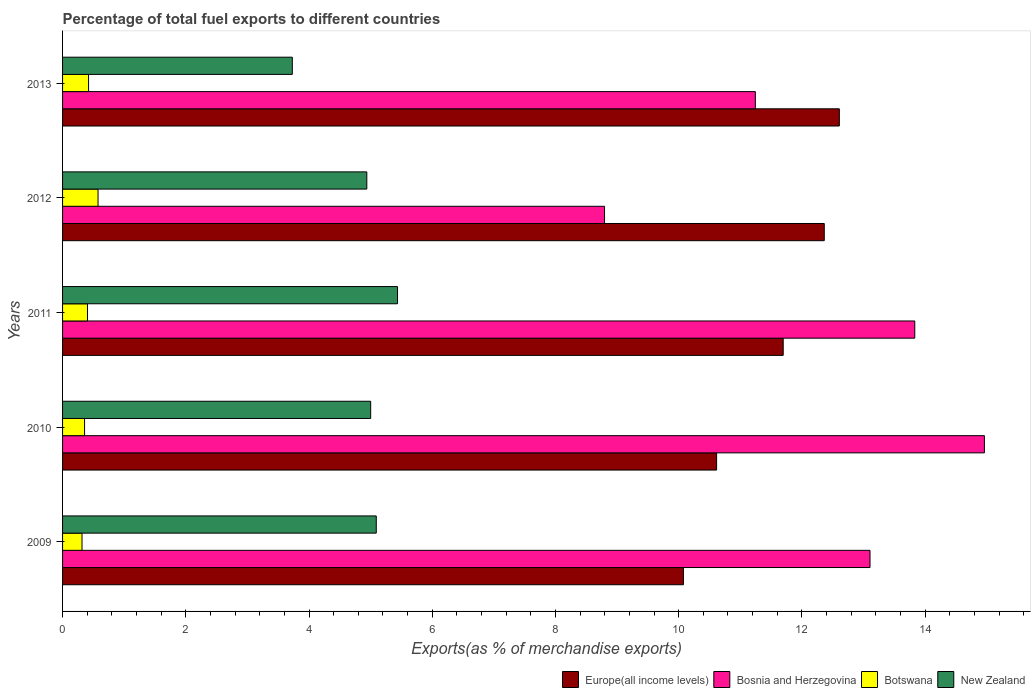How many groups of bars are there?
Your answer should be very brief. 5. Are the number of bars on each tick of the Y-axis equal?
Provide a short and direct response. Yes. How many bars are there on the 4th tick from the top?
Your response must be concise. 4. How many bars are there on the 3rd tick from the bottom?
Your answer should be compact. 4. What is the label of the 2nd group of bars from the top?
Provide a short and direct response. 2012. What is the percentage of exports to different countries in Botswana in 2010?
Your response must be concise. 0.36. Across all years, what is the maximum percentage of exports to different countries in New Zealand?
Your answer should be compact. 5.44. Across all years, what is the minimum percentage of exports to different countries in Botswana?
Keep it short and to the point. 0.32. In which year was the percentage of exports to different countries in Europe(all income levels) minimum?
Your answer should be compact. 2009. What is the total percentage of exports to different countries in Bosnia and Herzegovina in the graph?
Provide a short and direct response. 61.94. What is the difference between the percentage of exports to different countries in Europe(all income levels) in 2010 and that in 2011?
Keep it short and to the point. -1.08. What is the difference between the percentage of exports to different countries in Bosnia and Herzegovina in 2010 and the percentage of exports to different countries in Europe(all income levels) in 2011?
Keep it short and to the point. 3.27. What is the average percentage of exports to different countries in Botswana per year?
Ensure brevity in your answer.  0.42. In the year 2011, what is the difference between the percentage of exports to different countries in New Zealand and percentage of exports to different countries in Bosnia and Herzegovina?
Provide a short and direct response. -8.4. What is the ratio of the percentage of exports to different countries in New Zealand in 2009 to that in 2013?
Provide a short and direct response. 1.37. Is the difference between the percentage of exports to different countries in New Zealand in 2009 and 2013 greater than the difference between the percentage of exports to different countries in Bosnia and Herzegovina in 2009 and 2013?
Provide a succinct answer. No. What is the difference between the highest and the second highest percentage of exports to different countries in Botswana?
Your answer should be compact. 0.15. What is the difference between the highest and the lowest percentage of exports to different countries in Botswana?
Your answer should be compact. 0.26. Is it the case that in every year, the sum of the percentage of exports to different countries in Botswana and percentage of exports to different countries in New Zealand is greater than the sum of percentage of exports to different countries in Bosnia and Herzegovina and percentage of exports to different countries in Europe(all income levels)?
Your answer should be compact. No. What does the 2nd bar from the top in 2009 represents?
Provide a succinct answer. Botswana. What does the 2nd bar from the bottom in 2012 represents?
Offer a very short reply. Bosnia and Herzegovina. Is it the case that in every year, the sum of the percentage of exports to different countries in Europe(all income levels) and percentage of exports to different countries in Bosnia and Herzegovina is greater than the percentage of exports to different countries in Botswana?
Make the answer very short. Yes. Does the graph contain any zero values?
Offer a very short reply. No. Where does the legend appear in the graph?
Provide a short and direct response. Bottom right. How many legend labels are there?
Give a very brief answer. 4. What is the title of the graph?
Your response must be concise. Percentage of total fuel exports to different countries. What is the label or title of the X-axis?
Ensure brevity in your answer.  Exports(as % of merchandise exports). What is the Exports(as % of merchandise exports) in Europe(all income levels) in 2009?
Ensure brevity in your answer.  10.08. What is the Exports(as % of merchandise exports) of Bosnia and Herzegovina in 2009?
Ensure brevity in your answer.  13.11. What is the Exports(as % of merchandise exports) in Botswana in 2009?
Your answer should be very brief. 0.32. What is the Exports(as % of merchandise exports) in New Zealand in 2009?
Offer a very short reply. 5.09. What is the Exports(as % of merchandise exports) of Europe(all income levels) in 2010?
Provide a succinct answer. 10.62. What is the Exports(as % of merchandise exports) of Bosnia and Herzegovina in 2010?
Make the answer very short. 14.96. What is the Exports(as % of merchandise exports) of Botswana in 2010?
Your answer should be compact. 0.36. What is the Exports(as % of merchandise exports) in New Zealand in 2010?
Your answer should be compact. 5. What is the Exports(as % of merchandise exports) in Europe(all income levels) in 2011?
Ensure brevity in your answer.  11.7. What is the Exports(as % of merchandise exports) of Bosnia and Herzegovina in 2011?
Keep it short and to the point. 13.83. What is the Exports(as % of merchandise exports) of Botswana in 2011?
Keep it short and to the point. 0.4. What is the Exports(as % of merchandise exports) in New Zealand in 2011?
Your response must be concise. 5.44. What is the Exports(as % of merchandise exports) in Europe(all income levels) in 2012?
Provide a short and direct response. 12.36. What is the Exports(as % of merchandise exports) in Bosnia and Herzegovina in 2012?
Your answer should be compact. 8.8. What is the Exports(as % of merchandise exports) of Botswana in 2012?
Your response must be concise. 0.58. What is the Exports(as % of merchandise exports) in New Zealand in 2012?
Offer a very short reply. 4.94. What is the Exports(as % of merchandise exports) in Europe(all income levels) in 2013?
Give a very brief answer. 12.61. What is the Exports(as % of merchandise exports) of Bosnia and Herzegovina in 2013?
Give a very brief answer. 11.24. What is the Exports(as % of merchandise exports) in Botswana in 2013?
Your response must be concise. 0.42. What is the Exports(as % of merchandise exports) in New Zealand in 2013?
Give a very brief answer. 3.73. Across all years, what is the maximum Exports(as % of merchandise exports) in Europe(all income levels)?
Your response must be concise. 12.61. Across all years, what is the maximum Exports(as % of merchandise exports) in Bosnia and Herzegovina?
Provide a short and direct response. 14.96. Across all years, what is the maximum Exports(as % of merchandise exports) of Botswana?
Provide a succinct answer. 0.58. Across all years, what is the maximum Exports(as % of merchandise exports) of New Zealand?
Keep it short and to the point. 5.44. Across all years, what is the minimum Exports(as % of merchandise exports) of Europe(all income levels)?
Make the answer very short. 10.08. Across all years, what is the minimum Exports(as % of merchandise exports) of Bosnia and Herzegovina?
Make the answer very short. 8.8. Across all years, what is the minimum Exports(as % of merchandise exports) in Botswana?
Offer a terse response. 0.32. Across all years, what is the minimum Exports(as % of merchandise exports) in New Zealand?
Your answer should be compact. 3.73. What is the total Exports(as % of merchandise exports) of Europe(all income levels) in the graph?
Your answer should be very brief. 57.36. What is the total Exports(as % of merchandise exports) of Bosnia and Herzegovina in the graph?
Offer a very short reply. 61.94. What is the total Exports(as % of merchandise exports) of Botswana in the graph?
Your answer should be compact. 2.08. What is the total Exports(as % of merchandise exports) in New Zealand in the graph?
Keep it short and to the point. 24.2. What is the difference between the Exports(as % of merchandise exports) of Europe(all income levels) in 2009 and that in 2010?
Offer a terse response. -0.54. What is the difference between the Exports(as % of merchandise exports) in Bosnia and Herzegovina in 2009 and that in 2010?
Keep it short and to the point. -1.86. What is the difference between the Exports(as % of merchandise exports) of Botswana in 2009 and that in 2010?
Provide a succinct answer. -0.04. What is the difference between the Exports(as % of merchandise exports) in New Zealand in 2009 and that in 2010?
Give a very brief answer. 0.09. What is the difference between the Exports(as % of merchandise exports) of Europe(all income levels) in 2009 and that in 2011?
Provide a short and direct response. -1.62. What is the difference between the Exports(as % of merchandise exports) in Bosnia and Herzegovina in 2009 and that in 2011?
Offer a terse response. -0.73. What is the difference between the Exports(as % of merchandise exports) of Botswana in 2009 and that in 2011?
Provide a short and direct response. -0.09. What is the difference between the Exports(as % of merchandise exports) of New Zealand in 2009 and that in 2011?
Your answer should be compact. -0.35. What is the difference between the Exports(as % of merchandise exports) in Europe(all income levels) in 2009 and that in 2012?
Offer a very short reply. -2.29. What is the difference between the Exports(as % of merchandise exports) in Bosnia and Herzegovina in 2009 and that in 2012?
Ensure brevity in your answer.  4.31. What is the difference between the Exports(as % of merchandise exports) in Botswana in 2009 and that in 2012?
Make the answer very short. -0.26. What is the difference between the Exports(as % of merchandise exports) of New Zealand in 2009 and that in 2012?
Provide a succinct answer. 0.15. What is the difference between the Exports(as % of merchandise exports) of Europe(all income levels) in 2009 and that in 2013?
Your answer should be very brief. -2.53. What is the difference between the Exports(as % of merchandise exports) in Bosnia and Herzegovina in 2009 and that in 2013?
Your answer should be very brief. 1.86. What is the difference between the Exports(as % of merchandise exports) of Botswana in 2009 and that in 2013?
Ensure brevity in your answer.  -0.11. What is the difference between the Exports(as % of merchandise exports) of New Zealand in 2009 and that in 2013?
Provide a succinct answer. 1.36. What is the difference between the Exports(as % of merchandise exports) in Europe(all income levels) in 2010 and that in 2011?
Offer a terse response. -1.08. What is the difference between the Exports(as % of merchandise exports) in Bosnia and Herzegovina in 2010 and that in 2011?
Your answer should be very brief. 1.13. What is the difference between the Exports(as % of merchandise exports) in Botswana in 2010 and that in 2011?
Offer a very short reply. -0.05. What is the difference between the Exports(as % of merchandise exports) of New Zealand in 2010 and that in 2011?
Make the answer very short. -0.44. What is the difference between the Exports(as % of merchandise exports) in Europe(all income levels) in 2010 and that in 2012?
Keep it short and to the point. -1.75. What is the difference between the Exports(as % of merchandise exports) of Bosnia and Herzegovina in 2010 and that in 2012?
Offer a terse response. 6.17. What is the difference between the Exports(as % of merchandise exports) of Botswana in 2010 and that in 2012?
Give a very brief answer. -0.22. What is the difference between the Exports(as % of merchandise exports) in New Zealand in 2010 and that in 2012?
Offer a terse response. 0.06. What is the difference between the Exports(as % of merchandise exports) in Europe(all income levels) in 2010 and that in 2013?
Provide a short and direct response. -1.99. What is the difference between the Exports(as % of merchandise exports) in Bosnia and Herzegovina in 2010 and that in 2013?
Offer a very short reply. 3.72. What is the difference between the Exports(as % of merchandise exports) in Botswana in 2010 and that in 2013?
Your answer should be very brief. -0.07. What is the difference between the Exports(as % of merchandise exports) of New Zealand in 2010 and that in 2013?
Your answer should be compact. 1.27. What is the difference between the Exports(as % of merchandise exports) of Europe(all income levels) in 2011 and that in 2012?
Your response must be concise. -0.67. What is the difference between the Exports(as % of merchandise exports) of Bosnia and Herzegovina in 2011 and that in 2012?
Provide a short and direct response. 5.04. What is the difference between the Exports(as % of merchandise exports) in Botswana in 2011 and that in 2012?
Offer a terse response. -0.17. What is the difference between the Exports(as % of merchandise exports) in New Zealand in 2011 and that in 2012?
Keep it short and to the point. 0.5. What is the difference between the Exports(as % of merchandise exports) in Europe(all income levels) in 2011 and that in 2013?
Offer a terse response. -0.91. What is the difference between the Exports(as % of merchandise exports) of Bosnia and Herzegovina in 2011 and that in 2013?
Your answer should be very brief. 2.59. What is the difference between the Exports(as % of merchandise exports) in Botswana in 2011 and that in 2013?
Offer a terse response. -0.02. What is the difference between the Exports(as % of merchandise exports) in New Zealand in 2011 and that in 2013?
Give a very brief answer. 1.71. What is the difference between the Exports(as % of merchandise exports) of Europe(all income levels) in 2012 and that in 2013?
Ensure brevity in your answer.  -0.24. What is the difference between the Exports(as % of merchandise exports) of Bosnia and Herzegovina in 2012 and that in 2013?
Provide a succinct answer. -2.45. What is the difference between the Exports(as % of merchandise exports) of Botswana in 2012 and that in 2013?
Ensure brevity in your answer.  0.15. What is the difference between the Exports(as % of merchandise exports) in New Zealand in 2012 and that in 2013?
Ensure brevity in your answer.  1.21. What is the difference between the Exports(as % of merchandise exports) in Europe(all income levels) in 2009 and the Exports(as % of merchandise exports) in Bosnia and Herzegovina in 2010?
Provide a short and direct response. -4.89. What is the difference between the Exports(as % of merchandise exports) in Europe(all income levels) in 2009 and the Exports(as % of merchandise exports) in Botswana in 2010?
Offer a terse response. 9.72. What is the difference between the Exports(as % of merchandise exports) of Europe(all income levels) in 2009 and the Exports(as % of merchandise exports) of New Zealand in 2010?
Your answer should be compact. 5.08. What is the difference between the Exports(as % of merchandise exports) of Bosnia and Herzegovina in 2009 and the Exports(as % of merchandise exports) of Botswana in 2010?
Offer a terse response. 12.75. What is the difference between the Exports(as % of merchandise exports) in Bosnia and Herzegovina in 2009 and the Exports(as % of merchandise exports) in New Zealand in 2010?
Keep it short and to the point. 8.1. What is the difference between the Exports(as % of merchandise exports) of Botswana in 2009 and the Exports(as % of merchandise exports) of New Zealand in 2010?
Offer a very short reply. -4.69. What is the difference between the Exports(as % of merchandise exports) of Europe(all income levels) in 2009 and the Exports(as % of merchandise exports) of Bosnia and Herzegovina in 2011?
Your response must be concise. -3.76. What is the difference between the Exports(as % of merchandise exports) of Europe(all income levels) in 2009 and the Exports(as % of merchandise exports) of Botswana in 2011?
Give a very brief answer. 9.67. What is the difference between the Exports(as % of merchandise exports) of Europe(all income levels) in 2009 and the Exports(as % of merchandise exports) of New Zealand in 2011?
Your answer should be compact. 4.64. What is the difference between the Exports(as % of merchandise exports) in Bosnia and Herzegovina in 2009 and the Exports(as % of merchandise exports) in Botswana in 2011?
Your answer should be very brief. 12.7. What is the difference between the Exports(as % of merchandise exports) of Bosnia and Herzegovina in 2009 and the Exports(as % of merchandise exports) of New Zealand in 2011?
Provide a succinct answer. 7.67. What is the difference between the Exports(as % of merchandise exports) in Botswana in 2009 and the Exports(as % of merchandise exports) in New Zealand in 2011?
Provide a succinct answer. -5.12. What is the difference between the Exports(as % of merchandise exports) in Europe(all income levels) in 2009 and the Exports(as % of merchandise exports) in Bosnia and Herzegovina in 2012?
Provide a succinct answer. 1.28. What is the difference between the Exports(as % of merchandise exports) in Europe(all income levels) in 2009 and the Exports(as % of merchandise exports) in Botswana in 2012?
Offer a terse response. 9.5. What is the difference between the Exports(as % of merchandise exports) in Europe(all income levels) in 2009 and the Exports(as % of merchandise exports) in New Zealand in 2012?
Your response must be concise. 5.14. What is the difference between the Exports(as % of merchandise exports) of Bosnia and Herzegovina in 2009 and the Exports(as % of merchandise exports) of Botswana in 2012?
Make the answer very short. 12.53. What is the difference between the Exports(as % of merchandise exports) in Bosnia and Herzegovina in 2009 and the Exports(as % of merchandise exports) in New Zealand in 2012?
Offer a terse response. 8.17. What is the difference between the Exports(as % of merchandise exports) of Botswana in 2009 and the Exports(as % of merchandise exports) of New Zealand in 2012?
Offer a very short reply. -4.62. What is the difference between the Exports(as % of merchandise exports) in Europe(all income levels) in 2009 and the Exports(as % of merchandise exports) in Bosnia and Herzegovina in 2013?
Ensure brevity in your answer.  -1.17. What is the difference between the Exports(as % of merchandise exports) in Europe(all income levels) in 2009 and the Exports(as % of merchandise exports) in Botswana in 2013?
Make the answer very short. 9.66. What is the difference between the Exports(as % of merchandise exports) in Europe(all income levels) in 2009 and the Exports(as % of merchandise exports) in New Zealand in 2013?
Provide a succinct answer. 6.35. What is the difference between the Exports(as % of merchandise exports) in Bosnia and Herzegovina in 2009 and the Exports(as % of merchandise exports) in Botswana in 2013?
Ensure brevity in your answer.  12.68. What is the difference between the Exports(as % of merchandise exports) of Bosnia and Herzegovina in 2009 and the Exports(as % of merchandise exports) of New Zealand in 2013?
Your answer should be compact. 9.38. What is the difference between the Exports(as % of merchandise exports) of Botswana in 2009 and the Exports(as % of merchandise exports) of New Zealand in 2013?
Your response must be concise. -3.41. What is the difference between the Exports(as % of merchandise exports) of Europe(all income levels) in 2010 and the Exports(as % of merchandise exports) of Bosnia and Herzegovina in 2011?
Your response must be concise. -3.22. What is the difference between the Exports(as % of merchandise exports) in Europe(all income levels) in 2010 and the Exports(as % of merchandise exports) in Botswana in 2011?
Give a very brief answer. 10.21. What is the difference between the Exports(as % of merchandise exports) of Europe(all income levels) in 2010 and the Exports(as % of merchandise exports) of New Zealand in 2011?
Offer a very short reply. 5.18. What is the difference between the Exports(as % of merchandise exports) in Bosnia and Herzegovina in 2010 and the Exports(as % of merchandise exports) in Botswana in 2011?
Your answer should be compact. 14.56. What is the difference between the Exports(as % of merchandise exports) of Bosnia and Herzegovina in 2010 and the Exports(as % of merchandise exports) of New Zealand in 2011?
Provide a short and direct response. 9.53. What is the difference between the Exports(as % of merchandise exports) of Botswana in 2010 and the Exports(as % of merchandise exports) of New Zealand in 2011?
Your answer should be compact. -5.08. What is the difference between the Exports(as % of merchandise exports) in Europe(all income levels) in 2010 and the Exports(as % of merchandise exports) in Bosnia and Herzegovina in 2012?
Your answer should be very brief. 1.82. What is the difference between the Exports(as % of merchandise exports) in Europe(all income levels) in 2010 and the Exports(as % of merchandise exports) in Botswana in 2012?
Your response must be concise. 10.04. What is the difference between the Exports(as % of merchandise exports) in Europe(all income levels) in 2010 and the Exports(as % of merchandise exports) in New Zealand in 2012?
Provide a succinct answer. 5.68. What is the difference between the Exports(as % of merchandise exports) in Bosnia and Herzegovina in 2010 and the Exports(as % of merchandise exports) in Botswana in 2012?
Offer a terse response. 14.39. What is the difference between the Exports(as % of merchandise exports) of Bosnia and Herzegovina in 2010 and the Exports(as % of merchandise exports) of New Zealand in 2012?
Provide a succinct answer. 10.02. What is the difference between the Exports(as % of merchandise exports) in Botswana in 2010 and the Exports(as % of merchandise exports) in New Zealand in 2012?
Ensure brevity in your answer.  -4.58. What is the difference between the Exports(as % of merchandise exports) in Europe(all income levels) in 2010 and the Exports(as % of merchandise exports) in Bosnia and Herzegovina in 2013?
Your answer should be very brief. -0.63. What is the difference between the Exports(as % of merchandise exports) of Europe(all income levels) in 2010 and the Exports(as % of merchandise exports) of Botswana in 2013?
Make the answer very short. 10.19. What is the difference between the Exports(as % of merchandise exports) of Europe(all income levels) in 2010 and the Exports(as % of merchandise exports) of New Zealand in 2013?
Make the answer very short. 6.89. What is the difference between the Exports(as % of merchandise exports) of Bosnia and Herzegovina in 2010 and the Exports(as % of merchandise exports) of Botswana in 2013?
Keep it short and to the point. 14.54. What is the difference between the Exports(as % of merchandise exports) of Bosnia and Herzegovina in 2010 and the Exports(as % of merchandise exports) of New Zealand in 2013?
Make the answer very short. 11.23. What is the difference between the Exports(as % of merchandise exports) in Botswana in 2010 and the Exports(as % of merchandise exports) in New Zealand in 2013?
Keep it short and to the point. -3.37. What is the difference between the Exports(as % of merchandise exports) of Europe(all income levels) in 2011 and the Exports(as % of merchandise exports) of Botswana in 2012?
Make the answer very short. 11.12. What is the difference between the Exports(as % of merchandise exports) of Europe(all income levels) in 2011 and the Exports(as % of merchandise exports) of New Zealand in 2012?
Make the answer very short. 6.76. What is the difference between the Exports(as % of merchandise exports) in Bosnia and Herzegovina in 2011 and the Exports(as % of merchandise exports) in Botswana in 2012?
Give a very brief answer. 13.26. What is the difference between the Exports(as % of merchandise exports) in Bosnia and Herzegovina in 2011 and the Exports(as % of merchandise exports) in New Zealand in 2012?
Offer a terse response. 8.89. What is the difference between the Exports(as % of merchandise exports) of Botswana in 2011 and the Exports(as % of merchandise exports) of New Zealand in 2012?
Offer a terse response. -4.53. What is the difference between the Exports(as % of merchandise exports) in Europe(all income levels) in 2011 and the Exports(as % of merchandise exports) in Bosnia and Herzegovina in 2013?
Offer a terse response. 0.45. What is the difference between the Exports(as % of merchandise exports) of Europe(all income levels) in 2011 and the Exports(as % of merchandise exports) of Botswana in 2013?
Your answer should be compact. 11.27. What is the difference between the Exports(as % of merchandise exports) of Europe(all income levels) in 2011 and the Exports(as % of merchandise exports) of New Zealand in 2013?
Your answer should be very brief. 7.97. What is the difference between the Exports(as % of merchandise exports) of Bosnia and Herzegovina in 2011 and the Exports(as % of merchandise exports) of Botswana in 2013?
Provide a short and direct response. 13.41. What is the difference between the Exports(as % of merchandise exports) of Bosnia and Herzegovina in 2011 and the Exports(as % of merchandise exports) of New Zealand in 2013?
Give a very brief answer. 10.1. What is the difference between the Exports(as % of merchandise exports) in Botswana in 2011 and the Exports(as % of merchandise exports) in New Zealand in 2013?
Ensure brevity in your answer.  -3.32. What is the difference between the Exports(as % of merchandise exports) in Europe(all income levels) in 2012 and the Exports(as % of merchandise exports) in Bosnia and Herzegovina in 2013?
Give a very brief answer. 1.12. What is the difference between the Exports(as % of merchandise exports) of Europe(all income levels) in 2012 and the Exports(as % of merchandise exports) of Botswana in 2013?
Offer a terse response. 11.94. What is the difference between the Exports(as % of merchandise exports) in Europe(all income levels) in 2012 and the Exports(as % of merchandise exports) in New Zealand in 2013?
Your response must be concise. 8.63. What is the difference between the Exports(as % of merchandise exports) in Bosnia and Herzegovina in 2012 and the Exports(as % of merchandise exports) in Botswana in 2013?
Make the answer very short. 8.37. What is the difference between the Exports(as % of merchandise exports) in Bosnia and Herzegovina in 2012 and the Exports(as % of merchandise exports) in New Zealand in 2013?
Make the answer very short. 5.07. What is the difference between the Exports(as % of merchandise exports) of Botswana in 2012 and the Exports(as % of merchandise exports) of New Zealand in 2013?
Provide a short and direct response. -3.15. What is the average Exports(as % of merchandise exports) of Europe(all income levels) per year?
Ensure brevity in your answer.  11.47. What is the average Exports(as % of merchandise exports) in Bosnia and Herzegovina per year?
Ensure brevity in your answer.  12.39. What is the average Exports(as % of merchandise exports) of Botswana per year?
Your answer should be compact. 0.41. What is the average Exports(as % of merchandise exports) in New Zealand per year?
Your answer should be very brief. 4.84. In the year 2009, what is the difference between the Exports(as % of merchandise exports) of Europe(all income levels) and Exports(as % of merchandise exports) of Bosnia and Herzegovina?
Your answer should be compact. -3.03. In the year 2009, what is the difference between the Exports(as % of merchandise exports) in Europe(all income levels) and Exports(as % of merchandise exports) in Botswana?
Give a very brief answer. 9.76. In the year 2009, what is the difference between the Exports(as % of merchandise exports) of Europe(all income levels) and Exports(as % of merchandise exports) of New Zealand?
Your answer should be very brief. 4.99. In the year 2009, what is the difference between the Exports(as % of merchandise exports) in Bosnia and Herzegovina and Exports(as % of merchandise exports) in Botswana?
Ensure brevity in your answer.  12.79. In the year 2009, what is the difference between the Exports(as % of merchandise exports) of Bosnia and Herzegovina and Exports(as % of merchandise exports) of New Zealand?
Make the answer very short. 8.01. In the year 2009, what is the difference between the Exports(as % of merchandise exports) of Botswana and Exports(as % of merchandise exports) of New Zealand?
Your answer should be compact. -4.78. In the year 2010, what is the difference between the Exports(as % of merchandise exports) of Europe(all income levels) and Exports(as % of merchandise exports) of Bosnia and Herzegovina?
Provide a short and direct response. -4.35. In the year 2010, what is the difference between the Exports(as % of merchandise exports) in Europe(all income levels) and Exports(as % of merchandise exports) in Botswana?
Offer a terse response. 10.26. In the year 2010, what is the difference between the Exports(as % of merchandise exports) in Europe(all income levels) and Exports(as % of merchandise exports) in New Zealand?
Offer a very short reply. 5.62. In the year 2010, what is the difference between the Exports(as % of merchandise exports) in Bosnia and Herzegovina and Exports(as % of merchandise exports) in Botswana?
Your answer should be very brief. 14.61. In the year 2010, what is the difference between the Exports(as % of merchandise exports) of Bosnia and Herzegovina and Exports(as % of merchandise exports) of New Zealand?
Make the answer very short. 9.96. In the year 2010, what is the difference between the Exports(as % of merchandise exports) in Botswana and Exports(as % of merchandise exports) in New Zealand?
Give a very brief answer. -4.64. In the year 2011, what is the difference between the Exports(as % of merchandise exports) in Europe(all income levels) and Exports(as % of merchandise exports) in Bosnia and Herzegovina?
Ensure brevity in your answer.  -2.14. In the year 2011, what is the difference between the Exports(as % of merchandise exports) of Europe(all income levels) and Exports(as % of merchandise exports) of Botswana?
Make the answer very short. 11.29. In the year 2011, what is the difference between the Exports(as % of merchandise exports) of Europe(all income levels) and Exports(as % of merchandise exports) of New Zealand?
Ensure brevity in your answer.  6.26. In the year 2011, what is the difference between the Exports(as % of merchandise exports) in Bosnia and Herzegovina and Exports(as % of merchandise exports) in Botswana?
Offer a very short reply. 13.43. In the year 2011, what is the difference between the Exports(as % of merchandise exports) of Bosnia and Herzegovina and Exports(as % of merchandise exports) of New Zealand?
Ensure brevity in your answer.  8.4. In the year 2011, what is the difference between the Exports(as % of merchandise exports) of Botswana and Exports(as % of merchandise exports) of New Zealand?
Keep it short and to the point. -5.03. In the year 2012, what is the difference between the Exports(as % of merchandise exports) of Europe(all income levels) and Exports(as % of merchandise exports) of Bosnia and Herzegovina?
Your response must be concise. 3.57. In the year 2012, what is the difference between the Exports(as % of merchandise exports) in Europe(all income levels) and Exports(as % of merchandise exports) in Botswana?
Provide a short and direct response. 11.79. In the year 2012, what is the difference between the Exports(as % of merchandise exports) in Europe(all income levels) and Exports(as % of merchandise exports) in New Zealand?
Ensure brevity in your answer.  7.43. In the year 2012, what is the difference between the Exports(as % of merchandise exports) of Bosnia and Herzegovina and Exports(as % of merchandise exports) of Botswana?
Give a very brief answer. 8.22. In the year 2012, what is the difference between the Exports(as % of merchandise exports) in Bosnia and Herzegovina and Exports(as % of merchandise exports) in New Zealand?
Make the answer very short. 3.86. In the year 2012, what is the difference between the Exports(as % of merchandise exports) in Botswana and Exports(as % of merchandise exports) in New Zealand?
Provide a succinct answer. -4.36. In the year 2013, what is the difference between the Exports(as % of merchandise exports) of Europe(all income levels) and Exports(as % of merchandise exports) of Bosnia and Herzegovina?
Your answer should be very brief. 1.36. In the year 2013, what is the difference between the Exports(as % of merchandise exports) of Europe(all income levels) and Exports(as % of merchandise exports) of Botswana?
Offer a very short reply. 12.19. In the year 2013, what is the difference between the Exports(as % of merchandise exports) in Europe(all income levels) and Exports(as % of merchandise exports) in New Zealand?
Provide a short and direct response. 8.88. In the year 2013, what is the difference between the Exports(as % of merchandise exports) in Bosnia and Herzegovina and Exports(as % of merchandise exports) in Botswana?
Your answer should be very brief. 10.82. In the year 2013, what is the difference between the Exports(as % of merchandise exports) of Bosnia and Herzegovina and Exports(as % of merchandise exports) of New Zealand?
Your response must be concise. 7.52. In the year 2013, what is the difference between the Exports(as % of merchandise exports) of Botswana and Exports(as % of merchandise exports) of New Zealand?
Provide a short and direct response. -3.31. What is the ratio of the Exports(as % of merchandise exports) of Europe(all income levels) in 2009 to that in 2010?
Make the answer very short. 0.95. What is the ratio of the Exports(as % of merchandise exports) of Bosnia and Herzegovina in 2009 to that in 2010?
Your answer should be very brief. 0.88. What is the ratio of the Exports(as % of merchandise exports) of Botswana in 2009 to that in 2010?
Make the answer very short. 0.88. What is the ratio of the Exports(as % of merchandise exports) of New Zealand in 2009 to that in 2010?
Your answer should be compact. 1.02. What is the ratio of the Exports(as % of merchandise exports) of Europe(all income levels) in 2009 to that in 2011?
Give a very brief answer. 0.86. What is the ratio of the Exports(as % of merchandise exports) in Bosnia and Herzegovina in 2009 to that in 2011?
Your answer should be compact. 0.95. What is the ratio of the Exports(as % of merchandise exports) in Botswana in 2009 to that in 2011?
Your answer should be compact. 0.78. What is the ratio of the Exports(as % of merchandise exports) of New Zealand in 2009 to that in 2011?
Provide a short and direct response. 0.94. What is the ratio of the Exports(as % of merchandise exports) of Europe(all income levels) in 2009 to that in 2012?
Give a very brief answer. 0.82. What is the ratio of the Exports(as % of merchandise exports) in Bosnia and Herzegovina in 2009 to that in 2012?
Your answer should be compact. 1.49. What is the ratio of the Exports(as % of merchandise exports) in Botswana in 2009 to that in 2012?
Ensure brevity in your answer.  0.55. What is the ratio of the Exports(as % of merchandise exports) of New Zealand in 2009 to that in 2012?
Provide a short and direct response. 1.03. What is the ratio of the Exports(as % of merchandise exports) in Europe(all income levels) in 2009 to that in 2013?
Make the answer very short. 0.8. What is the ratio of the Exports(as % of merchandise exports) in Bosnia and Herzegovina in 2009 to that in 2013?
Offer a very short reply. 1.17. What is the ratio of the Exports(as % of merchandise exports) in Botswana in 2009 to that in 2013?
Keep it short and to the point. 0.75. What is the ratio of the Exports(as % of merchandise exports) of New Zealand in 2009 to that in 2013?
Your answer should be compact. 1.37. What is the ratio of the Exports(as % of merchandise exports) in Europe(all income levels) in 2010 to that in 2011?
Offer a terse response. 0.91. What is the ratio of the Exports(as % of merchandise exports) in Bosnia and Herzegovina in 2010 to that in 2011?
Provide a succinct answer. 1.08. What is the ratio of the Exports(as % of merchandise exports) in Botswana in 2010 to that in 2011?
Keep it short and to the point. 0.88. What is the ratio of the Exports(as % of merchandise exports) of New Zealand in 2010 to that in 2011?
Make the answer very short. 0.92. What is the ratio of the Exports(as % of merchandise exports) in Europe(all income levels) in 2010 to that in 2012?
Your response must be concise. 0.86. What is the ratio of the Exports(as % of merchandise exports) in Bosnia and Herzegovina in 2010 to that in 2012?
Ensure brevity in your answer.  1.7. What is the ratio of the Exports(as % of merchandise exports) in Botswana in 2010 to that in 2012?
Offer a terse response. 0.62. What is the ratio of the Exports(as % of merchandise exports) in New Zealand in 2010 to that in 2012?
Keep it short and to the point. 1.01. What is the ratio of the Exports(as % of merchandise exports) of Europe(all income levels) in 2010 to that in 2013?
Your answer should be compact. 0.84. What is the ratio of the Exports(as % of merchandise exports) in Bosnia and Herzegovina in 2010 to that in 2013?
Offer a terse response. 1.33. What is the ratio of the Exports(as % of merchandise exports) in Botswana in 2010 to that in 2013?
Your answer should be compact. 0.85. What is the ratio of the Exports(as % of merchandise exports) in New Zealand in 2010 to that in 2013?
Keep it short and to the point. 1.34. What is the ratio of the Exports(as % of merchandise exports) in Europe(all income levels) in 2011 to that in 2012?
Your answer should be compact. 0.95. What is the ratio of the Exports(as % of merchandise exports) of Bosnia and Herzegovina in 2011 to that in 2012?
Provide a short and direct response. 1.57. What is the ratio of the Exports(as % of merchandise exports) of Botswana in 2011 to that in 2012?
Offer a very short reply. 0.7. What is the ratio of the Exports(as % of merchandise exports) in New Zealand in 2011 to that in 2012?
Provide a succinct answer. 1.1. What is the ratio of the Exports(as % of merchandise exports) in Europe(all income levels) in 2011 to that in 2013?
Provide a short and direct response. 0.93. What is the ratio of the Exports(as % of merchandise exports) of Bosnia and Herzegovina in 2011 to that in 2013?
Provide a succinct answer. 1.23. What is the ratio of the Exports(as % of merchandise exports) in Botswana in 2011 to that in 2013?
Make the answer very short. 0.96. What is the ratio of the Exports(as % of merchandise exports) of New Zealand in 2011 to that in 2013?
Make the answer very short. 1.46. What is the ratio of the Exports(as % of merchandise exports) of Europe(all income levels) in 2012 to that in 2013?
Ensure brevity in your answer.  0.98. What is the ratio of the Exports(as % of merchandise exports) of Bosnia and Herzegovina in 2012 to that in 2013?
Offer a very short reply. 0.78. What is the ratio of the Exports(as % of merchandise exports) of Botswana in 2012 to that in 2013?
Offer a terse response. 1.36. What is the ratio of the Exports(as % of merchandise exports) in New Zealand in 2012 to that in 2013?
Give a very brief answer. 1.32. What is the difference between the highest and the second highest Exports(as % of merchandise exports) of Europe(all income levels)?
Ensure brevity in your answer.  0.24. What is the difference between the highest and the second highest Exports(as % of merchandise exports) in Bosnia and Herzegovina?
Provide a short and direct response. 1.13. What is the difference between the highest and the second highest Exports(as % of merchandise exports) in Botswana?
Your answer should be compact. 0.15. What is the difference between the highest and the second highest Exports(as % of merchandise exports) of New Zealand?
Offer a terse response. 0.35. What is the difference between the highest and the lowest Exports(as % of merchandise exports) of Europe(all income levels)?
Give a very brief answer. 2.53. What is the difference between the highest and the lowest Exports(as % of merchandise exports) of Bosnia and Herzegovina?
Offer a terse response. 6.17. What is the difference between the highest and the lowest Exports(as % of merchandise exports) of Botswana?
Offer a very short reply. 0.26. What is the difference between the highest and the lowest Exports(as % of merchandise exports) in New Zealand?
Provide a short and direct response. 1.71. 